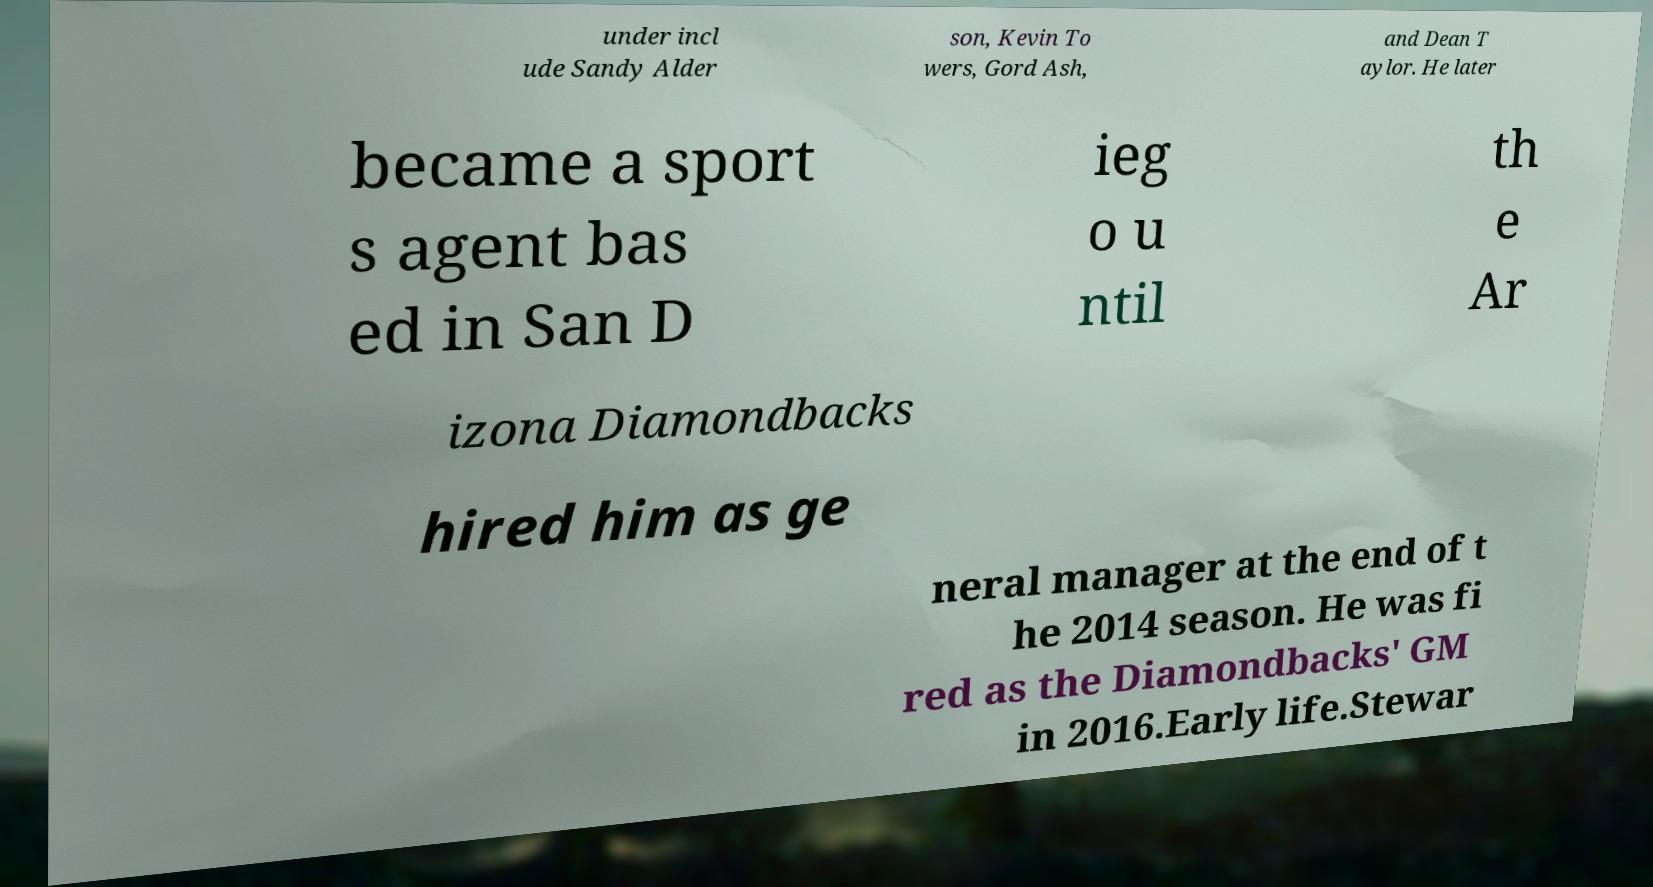Please identify and transcribe the text found in this image. under incl ude Sandy Alder son, Kevin To wers, Gord Ash, and Dean T aylor. He later became a sport s agent bas ed in San D ieg o u ntil th e Ar izona Diamondbacks hired him as ge neral manager at the end of t he 2014 season. He was fi red as the Diamondbacks' GM in 2016.Early life.Stewar 